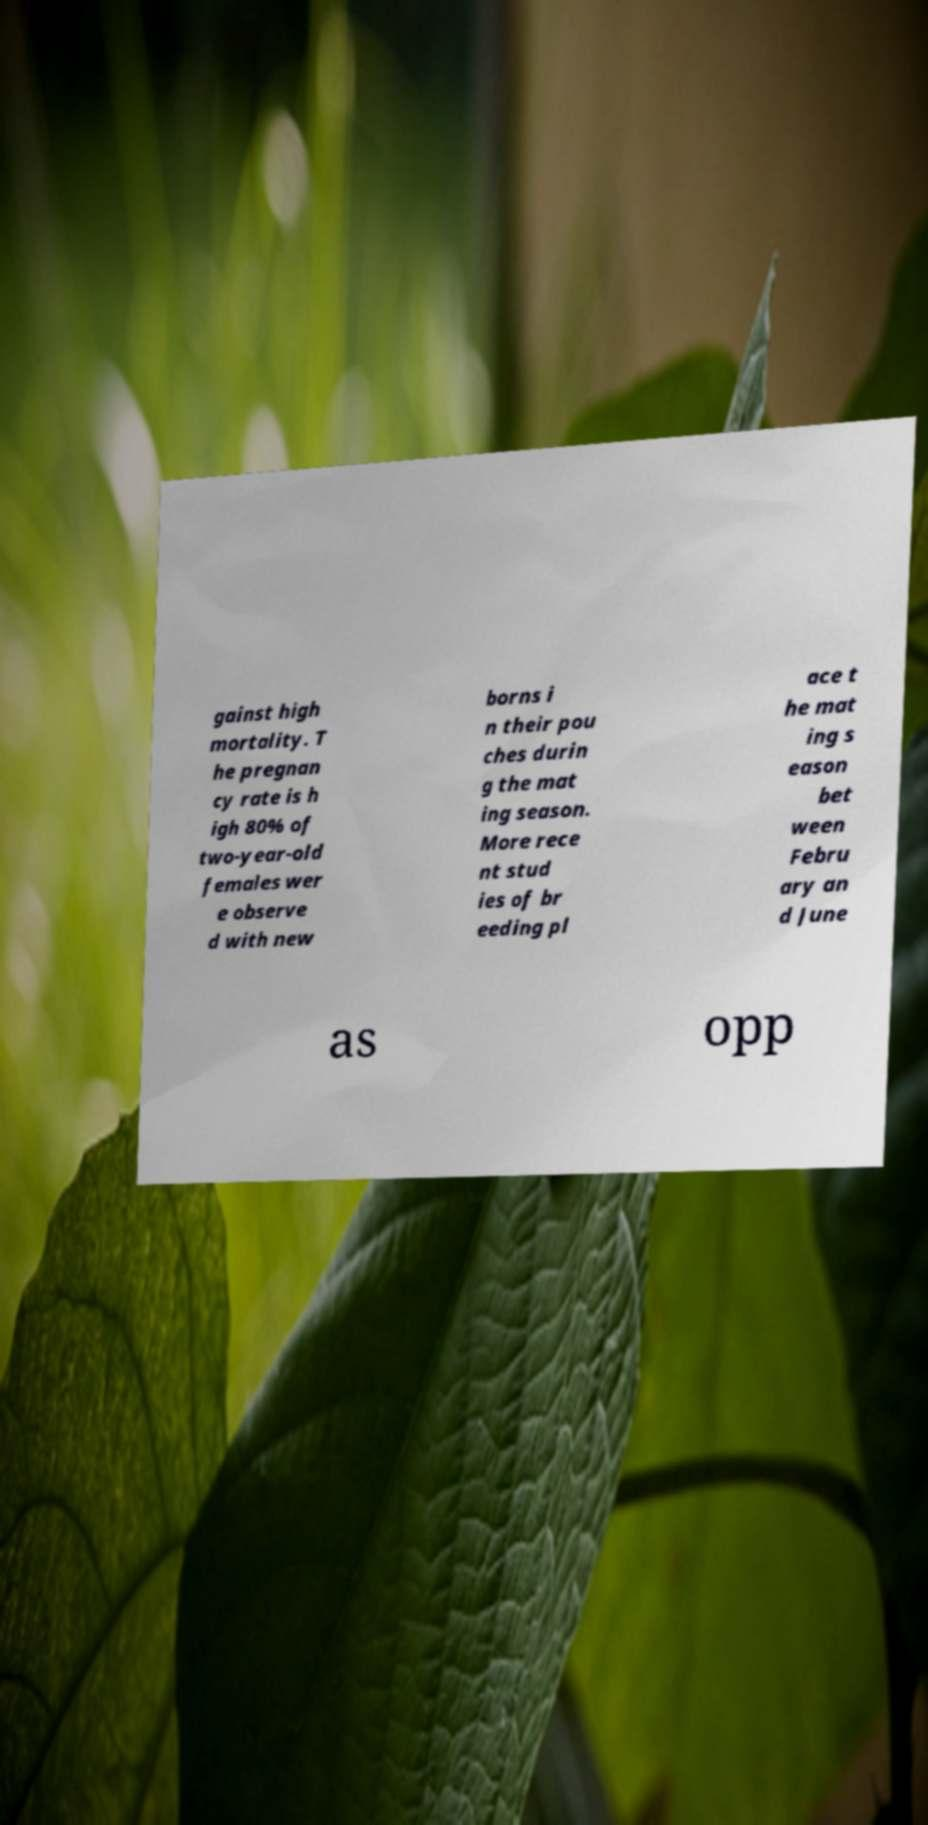I need the written content from this picture converted into text. Can you do that? gainst high mortality. T he pregnan cy rate is h igh 80% of two-year-old females wer e observe d with new borns i n their pou ches durin g the mat ing season. More rece nt stud ies of br eeding pl ace t he mat ing s eason bet ween Febru ary an d June as opp 